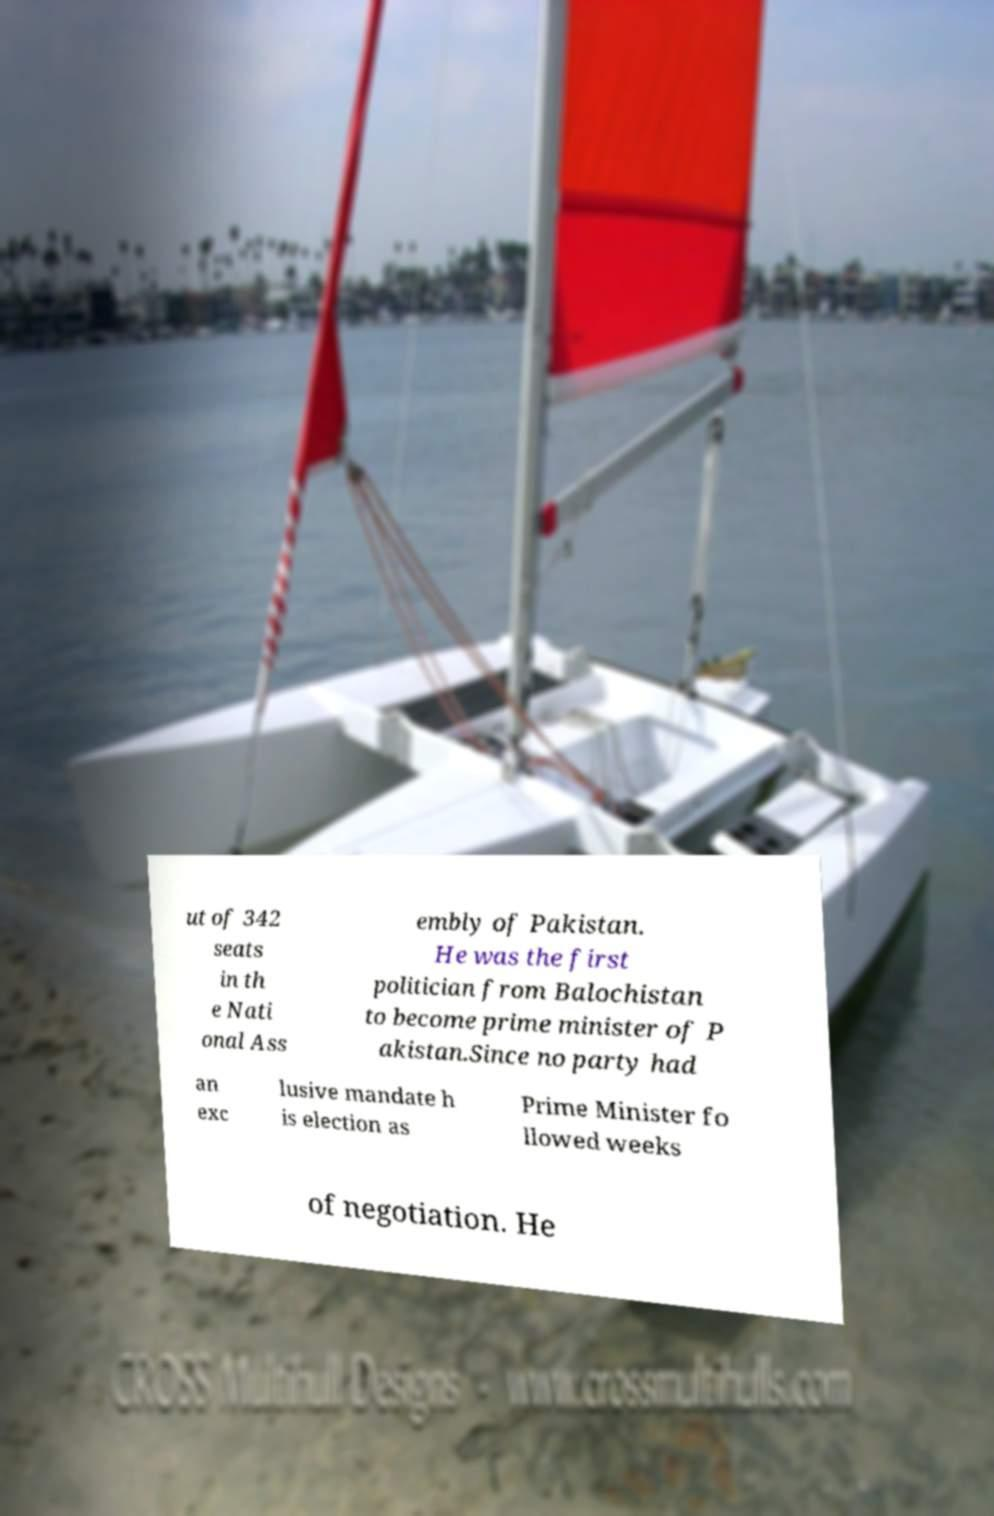Please identify and transcribe the text found in this image. ut of 342 seats in th e Nati onal Ass embly of Pakistan. He was the first politician from Balochistan to become prime minister of P akistan.Since no party had an exc lusive mandate h is election as Prime Minister fo llowed weeks of negotiation. He 